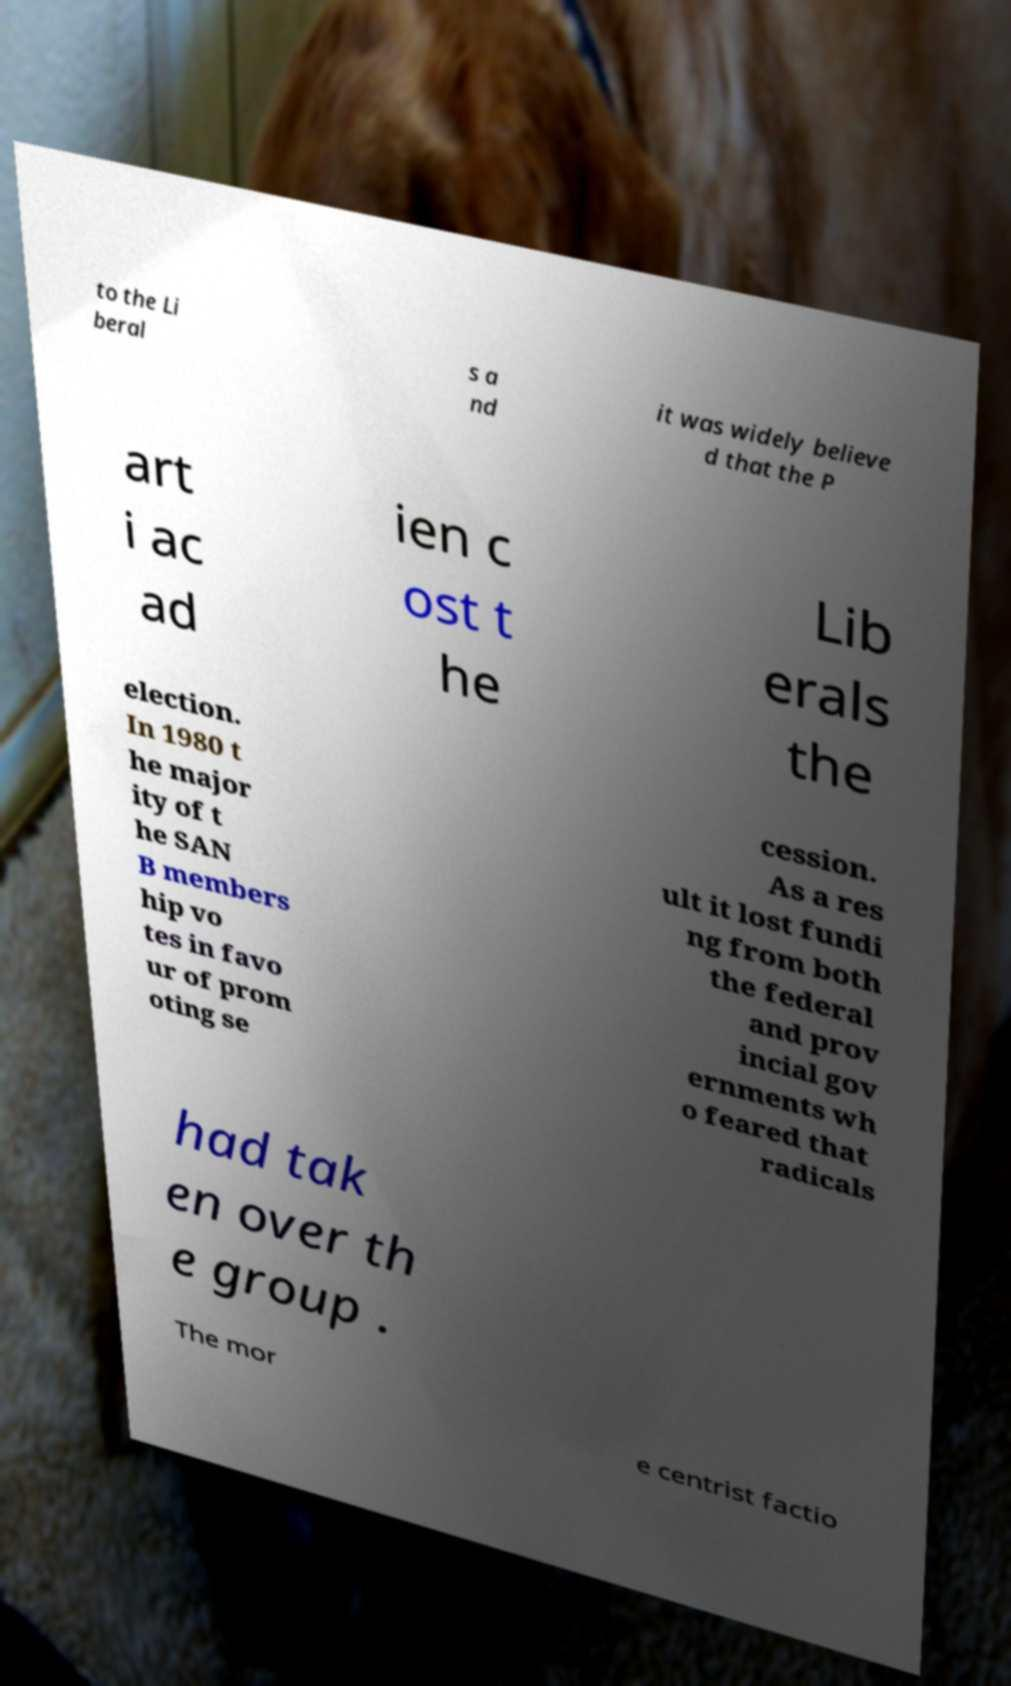Could you extract and type out the text from this image? to the Li beral s a nd it was widely believe d that the P art i ac ad ien c ost t he Lib erals the election. In 1980 t he major ity of t he SAN B members hip vo tes in favo ur of prom oting se cession. As a res ult it lost fundi ng from both the federal and prov incial gov ernments wh o feared that radicals had tak en over th e group . The mor e centrist factio 